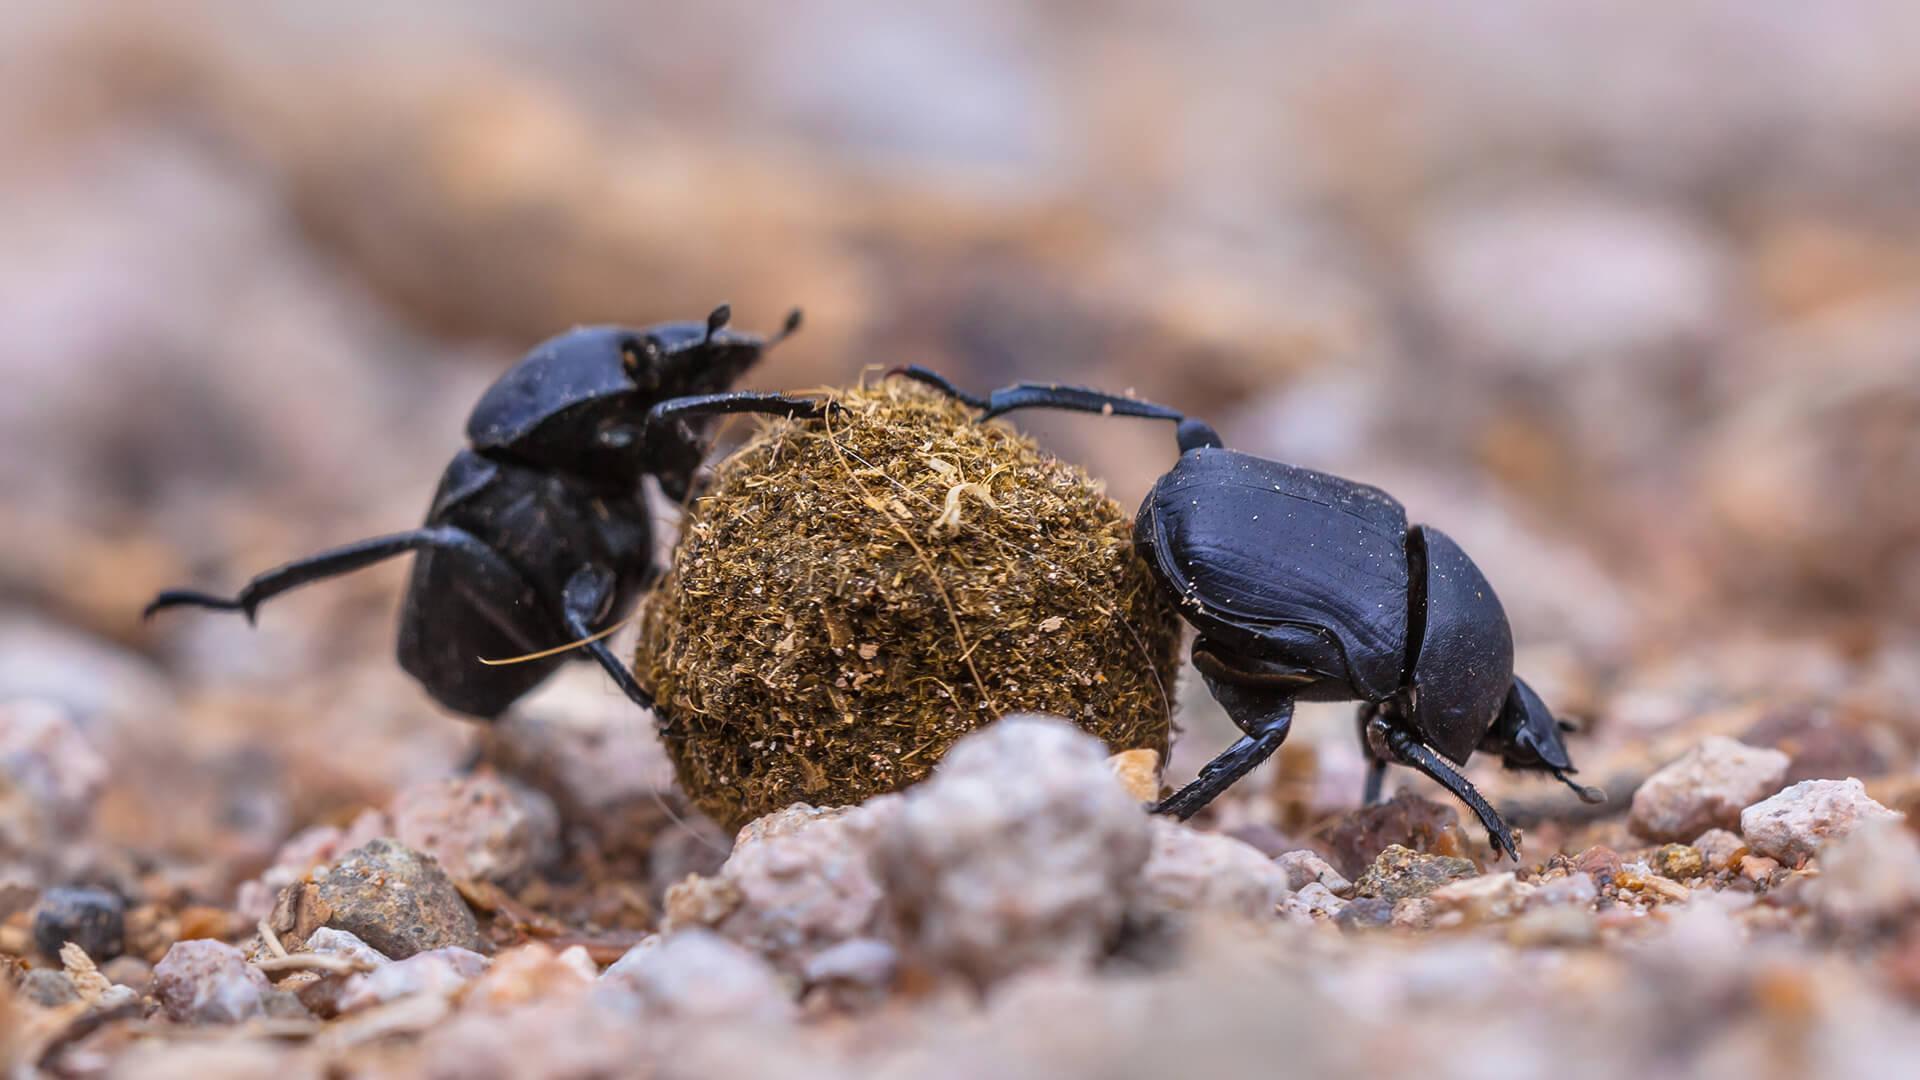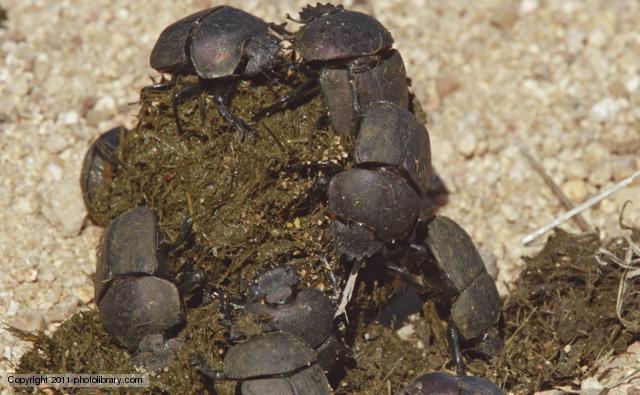The first image is the image on the left, the second image is the image on the right. Assess this claim about the two images: "Each image has at least 2 dung beetles interacting with a piece of dung.". Correct or not? Answer yes or no. Yes. The first image is the image on the left, the second image is the image on the right. For the images shown, is this caption "There are at most three beetles." true? Answer yes or no. No. 